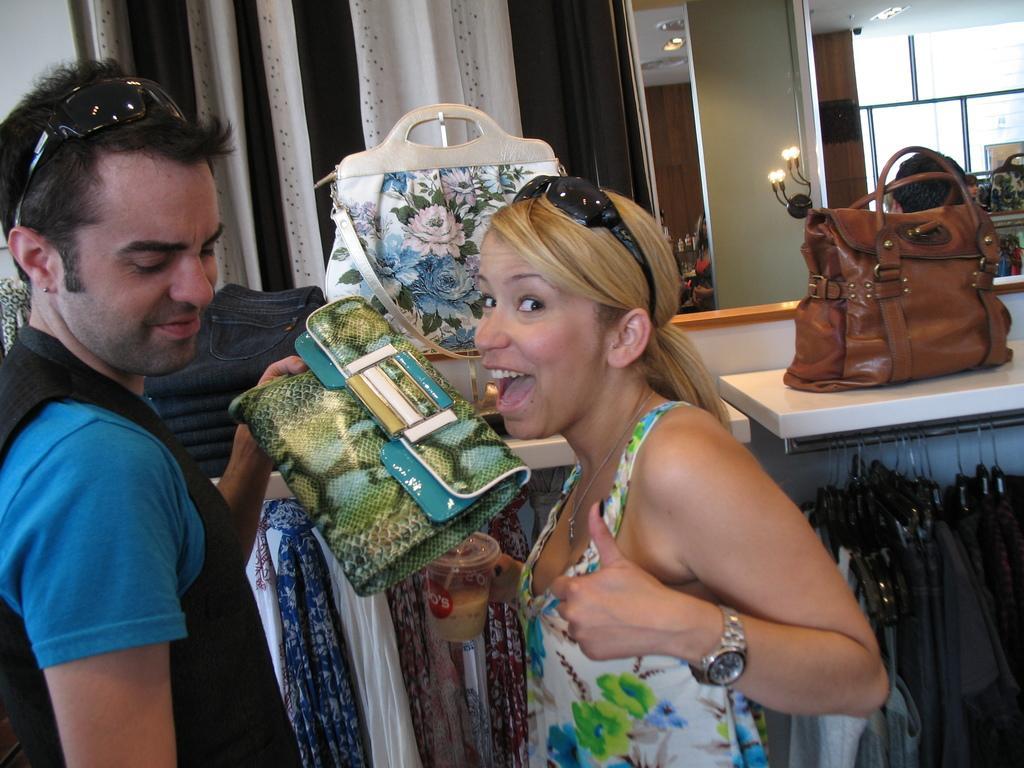Can you describe this image briefly? In the image we can see two persons were standing and holding hand bag and they were smiling. In the background there is a curtain,table,handbag,light and clothes. 